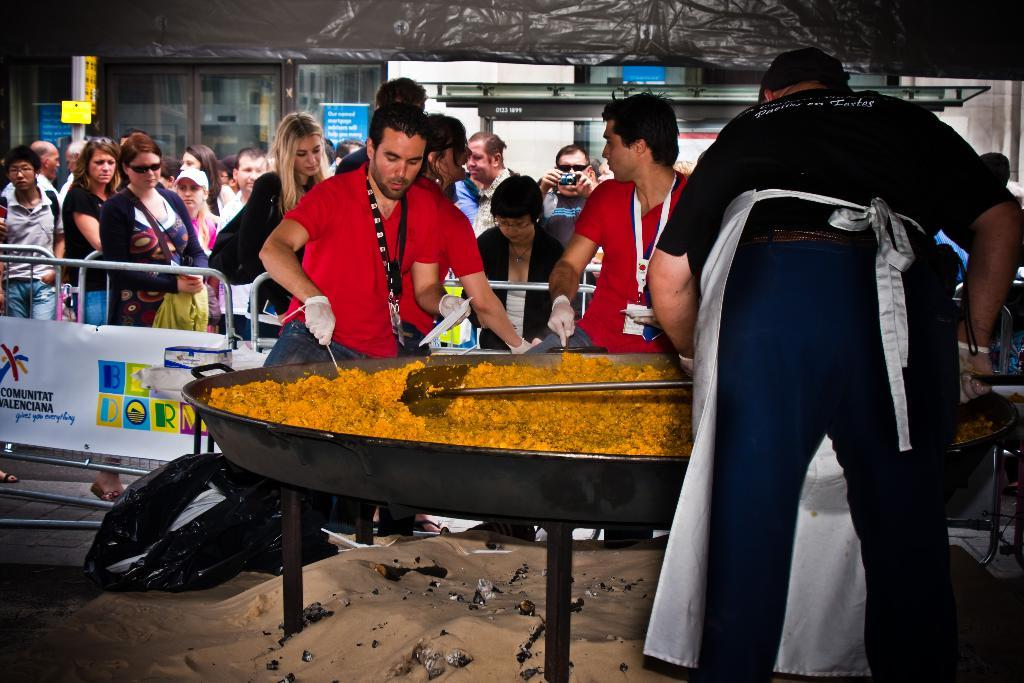What type of structure can be seen in the image? There is fencing in the image. What else is present in the image besides the fencing? There are boards, people, and a big bowl with food in the image. Can you describe the people in the image? There are people standing in the image, and some of them are holding something. What might be in the big bowl? The big bowl contains food. How many people have given their approval in the image? There is no indication in the image that people are giving their approval, so it cannot be determined. 